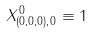<formula> <loc_0><loc_0><loc_500><loc_500>X ^ { 0 } _ { ( 0 , 0 , 0 ) , 0 } \equiv 1</formula> 